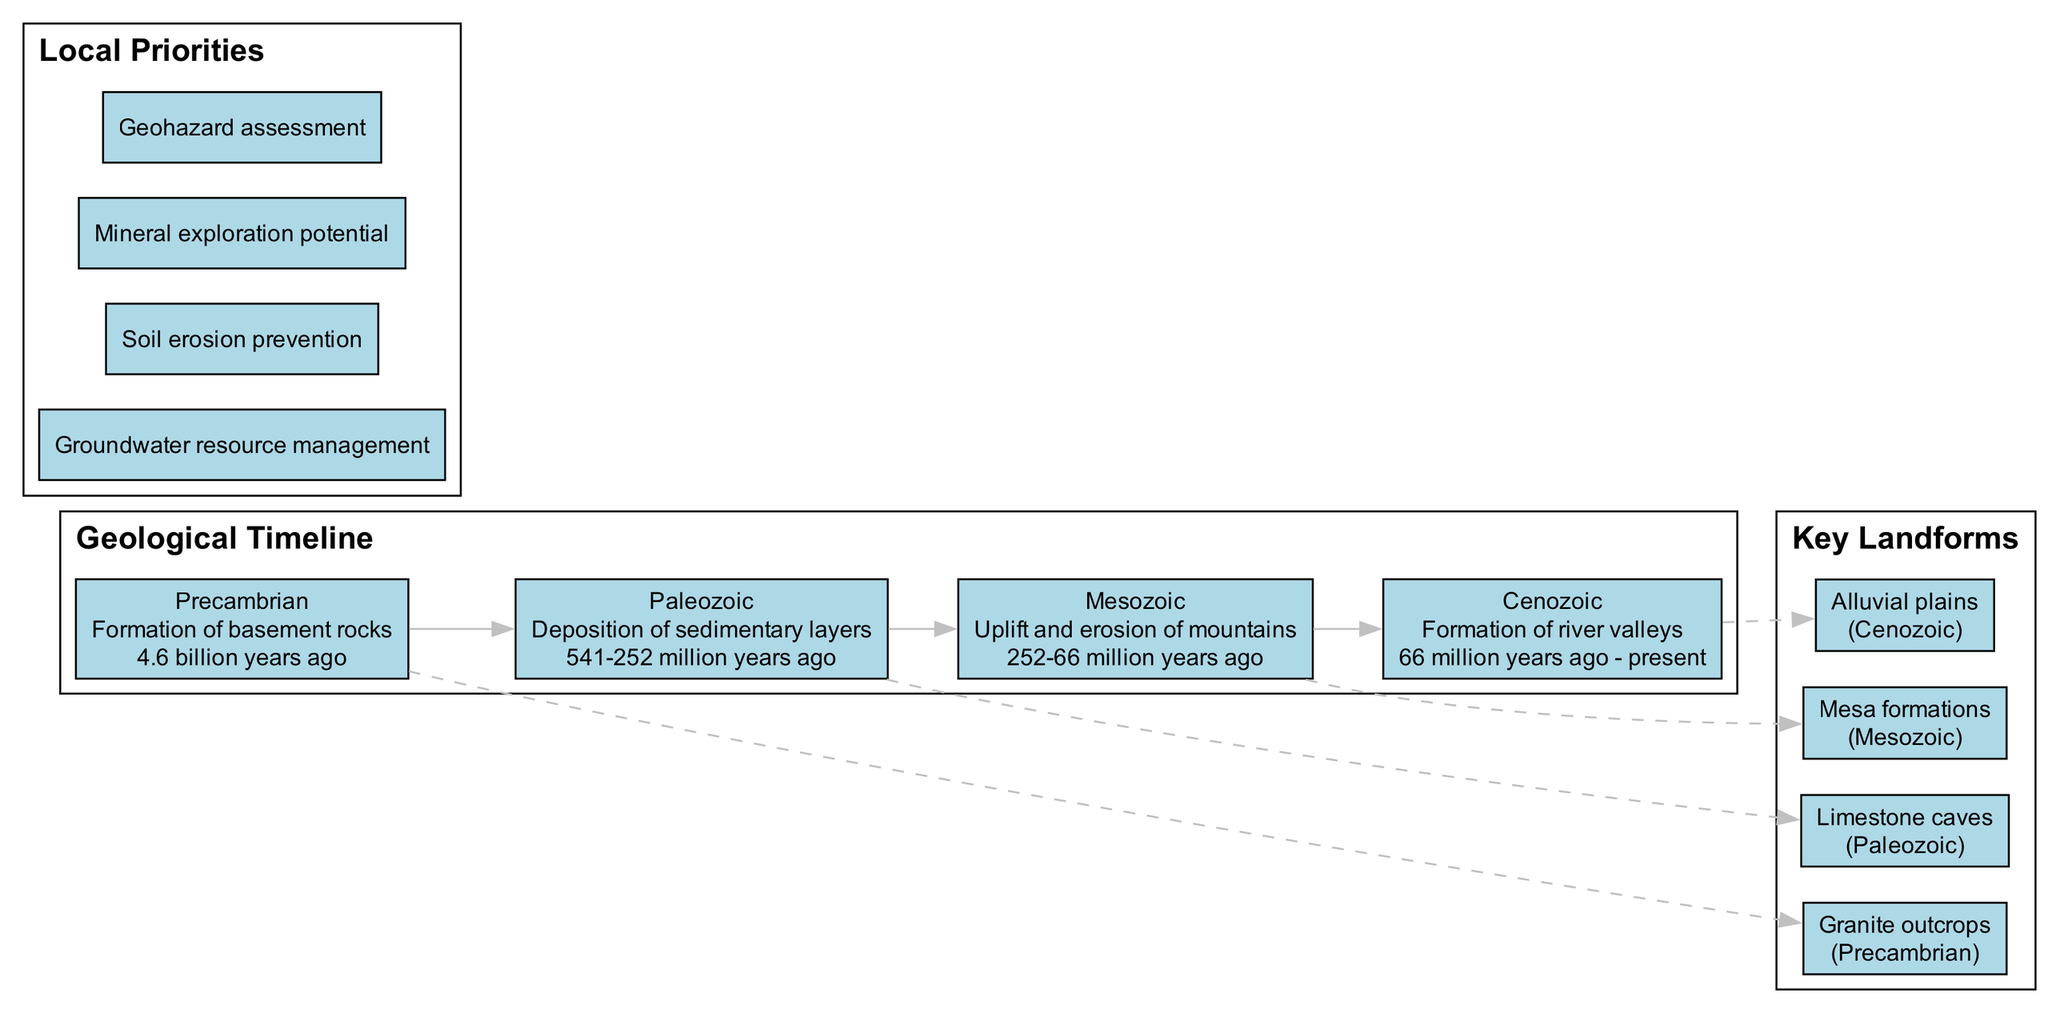What event is associated with the Paleozoic era? The diagram indicates that the event related to the Paleozoic era is the "Deposition of sedimentary layers." This is directly stated in the timeline section for the Paleozoic era.
Answer: Deposition of sedimentary layers How many key landforms are shown in the diagram? The diagram lists four key landforms, which include Granite outcrops, Limestone caves, Mesa formations, and Alluvial plains. Counting these gives us the total number.
Answer: 4 Which key landform was formed during the Mesozoic era? According to the diagram, Mesa formations are listed under the key landforms section with the formation period identified as Mesozoic. This directly corresponds to the question.
Answer: Mesa formations What is the date range for the Cenozoic era? The diagram shows that the Cenozoic era spans from "66 million years ago - present." This date range is clearly labeled in the timeline section for that era.
Answer: 66 million years ago - present Which geological event occurred 4.6 billion years ago? The timeline in the diagram specifies that the formation of basement rocks took place during the Precambrian era, which dates back to 4.6 billion years ago. This is where the specific date can be found.
Answer: Formation of basement rocks Which landform is associated with groundwater resource management? The diagram does not directly link landforms to local priorities; however, the Alluvial plains, formed in the Cenozoic era, are typically associated with groundwater resources, making them relevant to this priority.
Answer: Alluvial plains How many eras are featured in the geological timeline? The diagram lists four distinct eras: Precambrian, Paleozoic, Mesozoic, and Cenozoic. By counting these listed eras, we can answer the question regarding the number of eras presented in the timeline.
Answer: 4 Which era features the event of uplift and erosion of mountains? The timeline highlights that the Mesozoic era is associated with the event of uplift and erosion of mountains, as stated in the events for that specific era.
Answer: Mesozoic What is the priority related to soil erosion prevention? Although not visually connected in the diagram, soil erosion prevention is explicitly listed as one of the local priorities. This information is directly referenced, allowing for a straightforward response.
Answer: Soil erosion prevention 